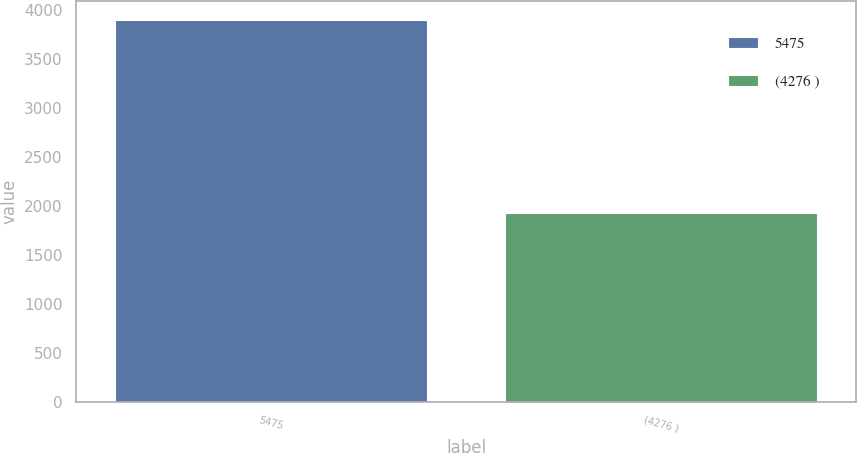<chart> <loc_0><loc_0><loc_500><loc_500><bar_chart><fcel>5475<fcel>(4276 )<nl><fcel>3903<fcel>1930<nl></chart> 